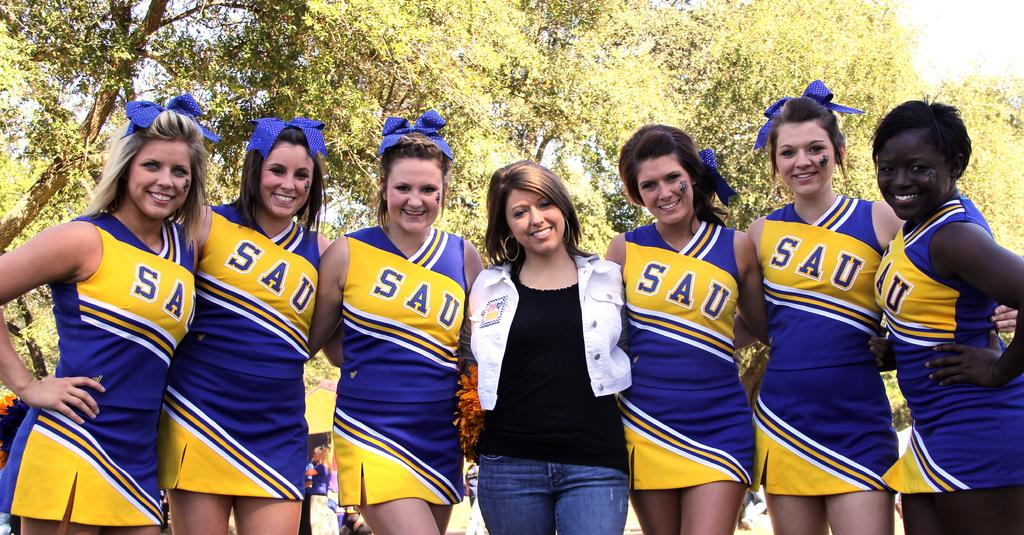<image>
Give a short and clear explanation of the subsequent image. Several SAU cheerleaders have blue bows in their hair. 